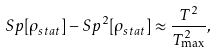<formula> <loc_0><loc_0><loc_500><loc_500>S p [ \rho _ { s t a t } ] - S p ^ { 2 } [ \rho _ { s t a t } ] \approx \frac { T ^ { 2 } } { T _ { \max } ^ { 2 } } ,</formula> 